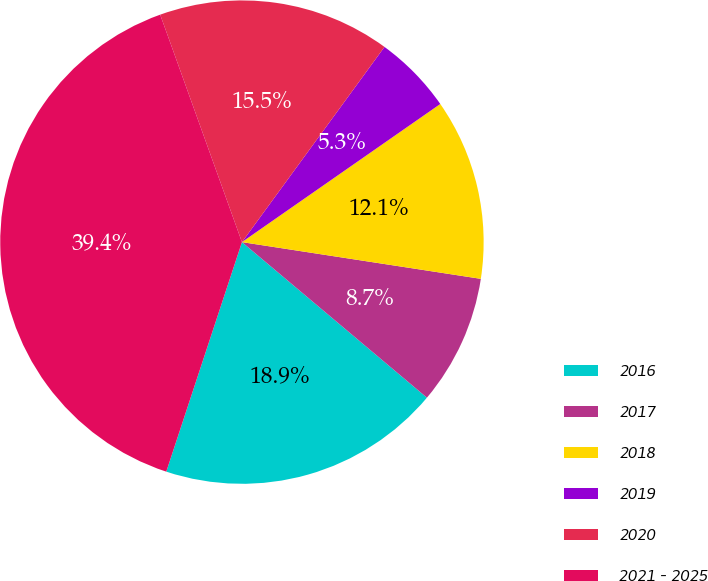<chart> <loc_0><loc_0><loc_500><loc_500><pie_chart><fcel>2016<fcel>2017<fcel>2018<fcel>2019<fcel>2020<fcel>2021 - 2025<nl><fcel>18.94%<fcel>8.7%<fcel>12.11%<fcel>5.28%<fcel>15.53%<fcel>39.44%<nl></chart> 